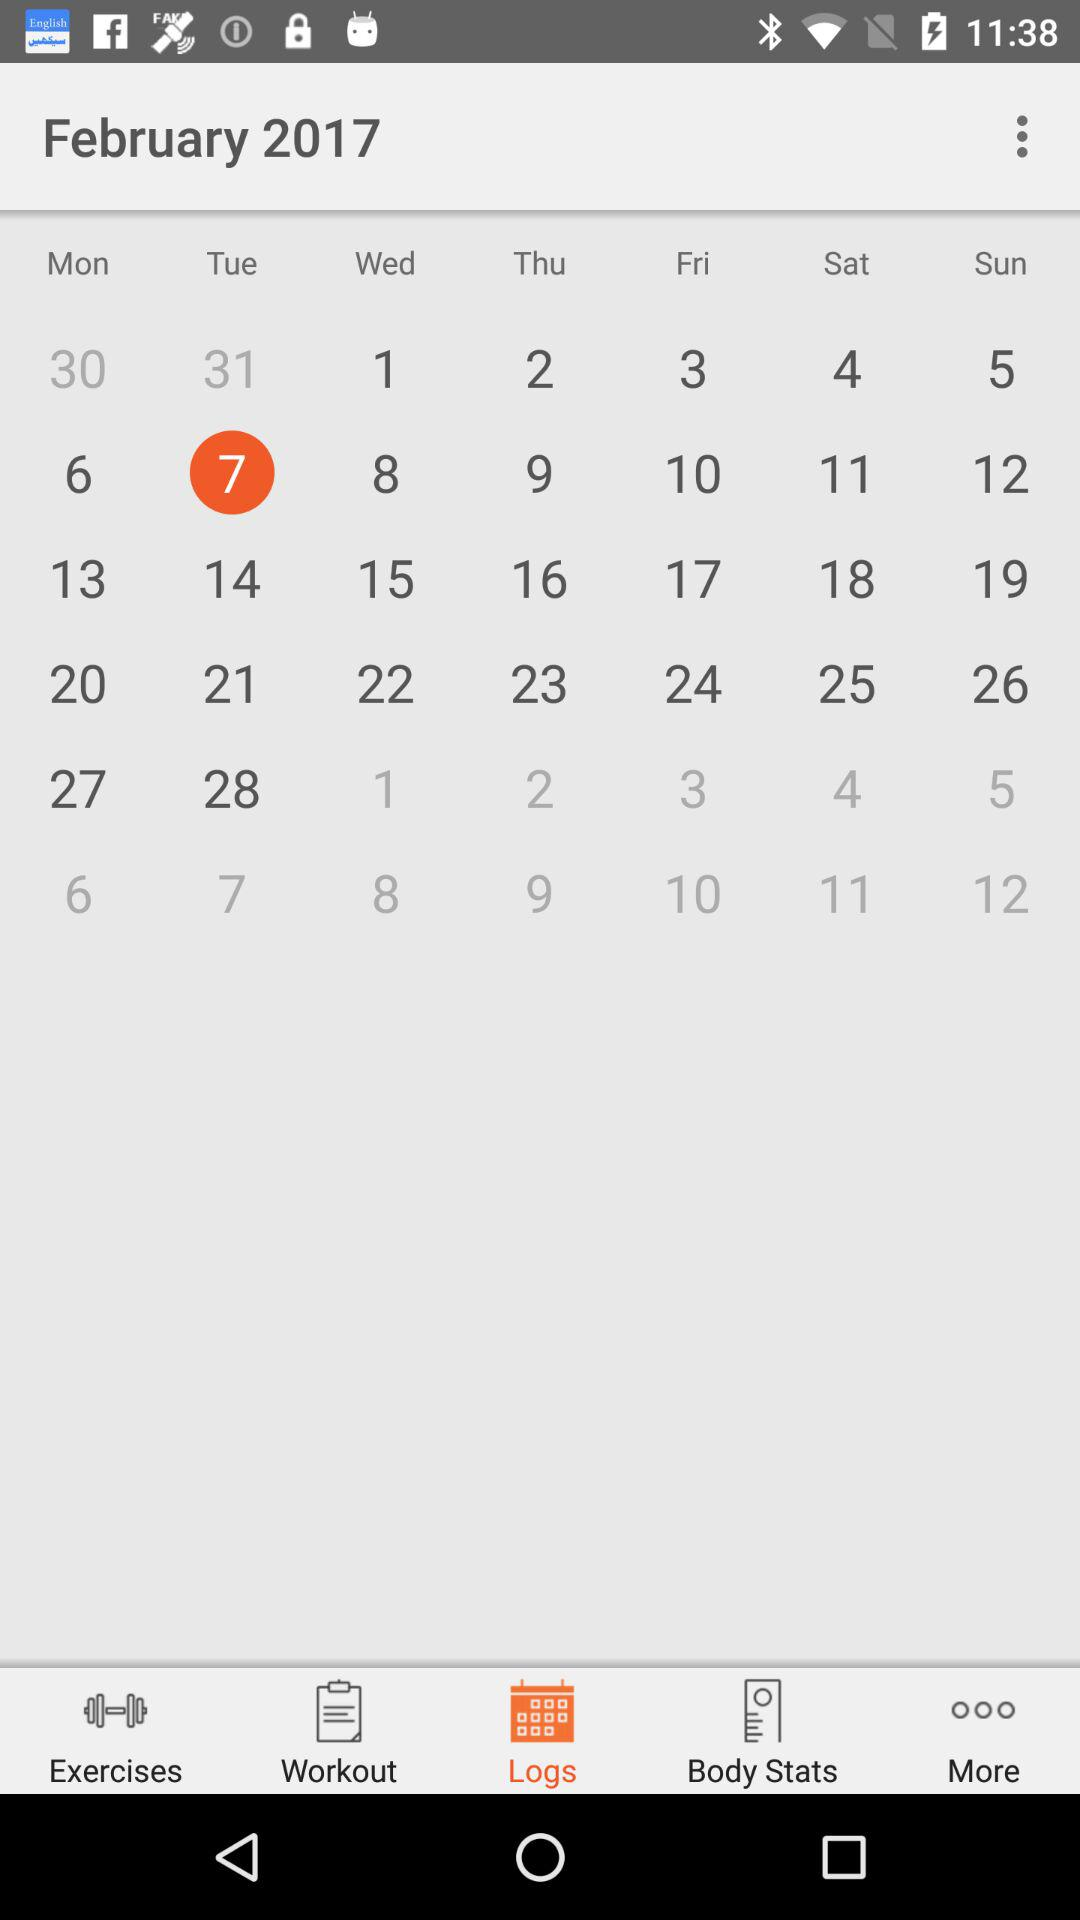What date is selected? The selected date is February 7, 2017. 